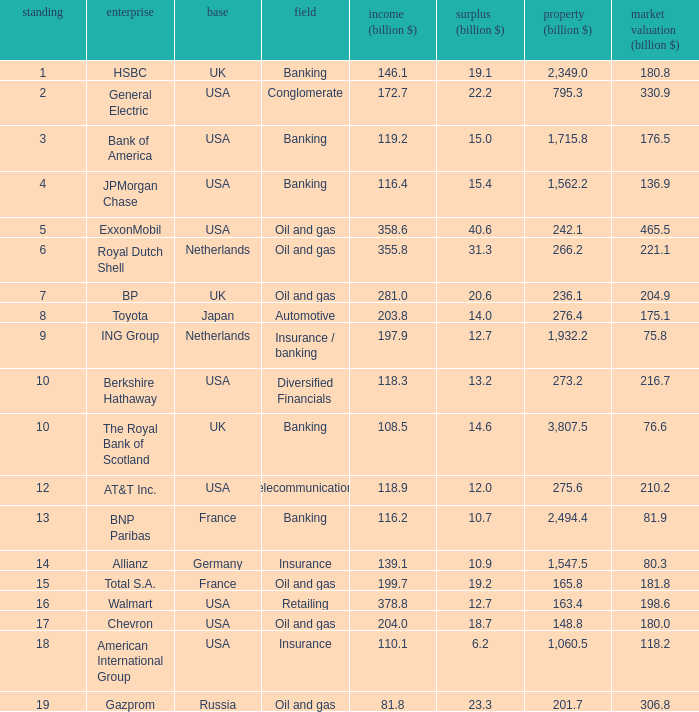What is the highest rank of a company that has 1,715.8 billion in assets?  3.0. 